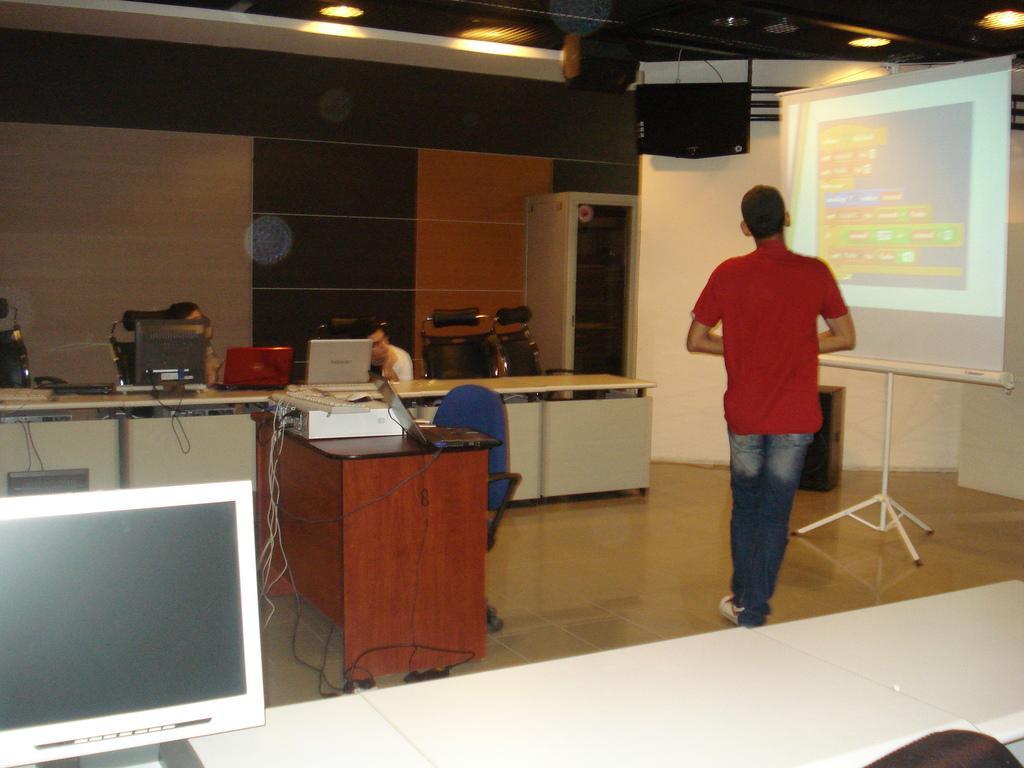In one or two sentences, can you explain what this image depicts? The image consists of a boy stood in front of a screen and above there ceiling lights and speakers and over to the wall there are laptops and people sat in front of them and in middle there is table and chair. 